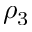Convert formula to latex. <formula><loc_0><loc_0><loc_500><loc_500>\rho _ { 3 }</formula> 